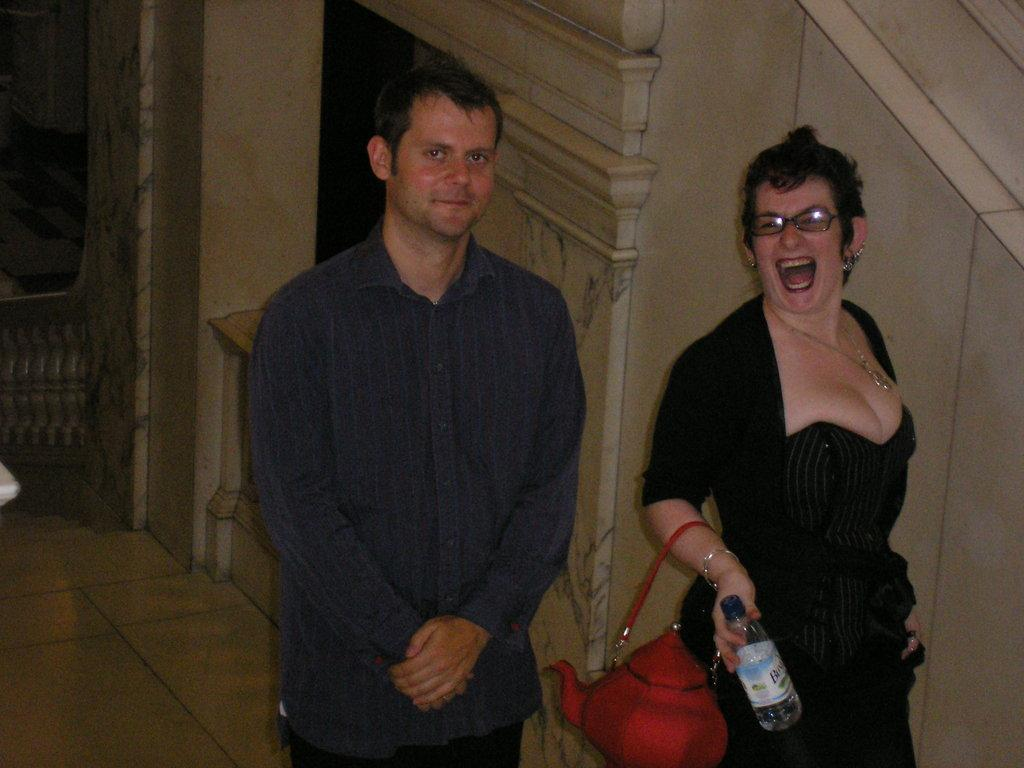How many people are in the image? There are two persons standing in the center of the image. What are the expressions on their faces? Both persons are smiling. What is the woman holding in her hands? The woman is holding a handbag and a water bottle. What can be seen in the background of the image? There is a wall and a pillar in the background of the image. What type of nail can be seen in the image? There is no nail present in the image. Is there a lift visible in the image? No, there is no lift visible in the image. 